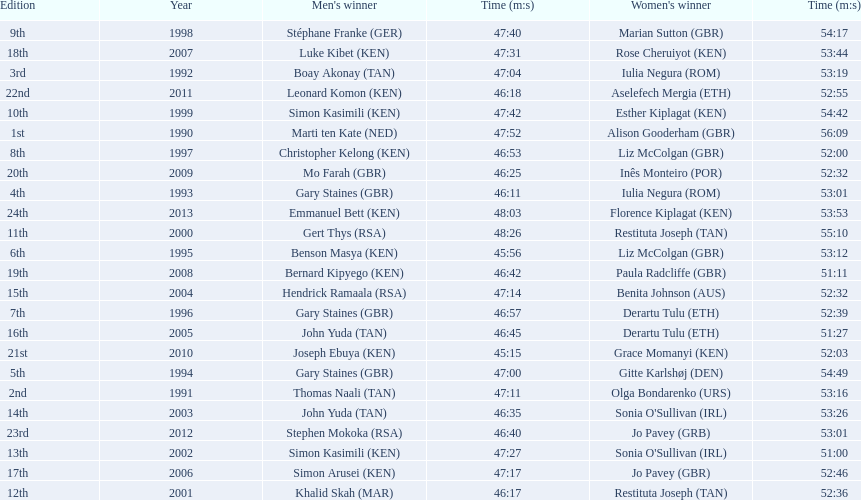What years were the races held? 1990, 1991, 1992, 1993, 1994, 1995, 1996, 1997, 1998, 1999, 2000, 2001, 2002, 2003, 2004, 2005, 2006, 2007, 2008, 2009, 2010, 2011, 2012, 2013. Who was the woman's winner of the 2003 race? Sonia O'Sullivan (IRL). What was her time? 53:26. 